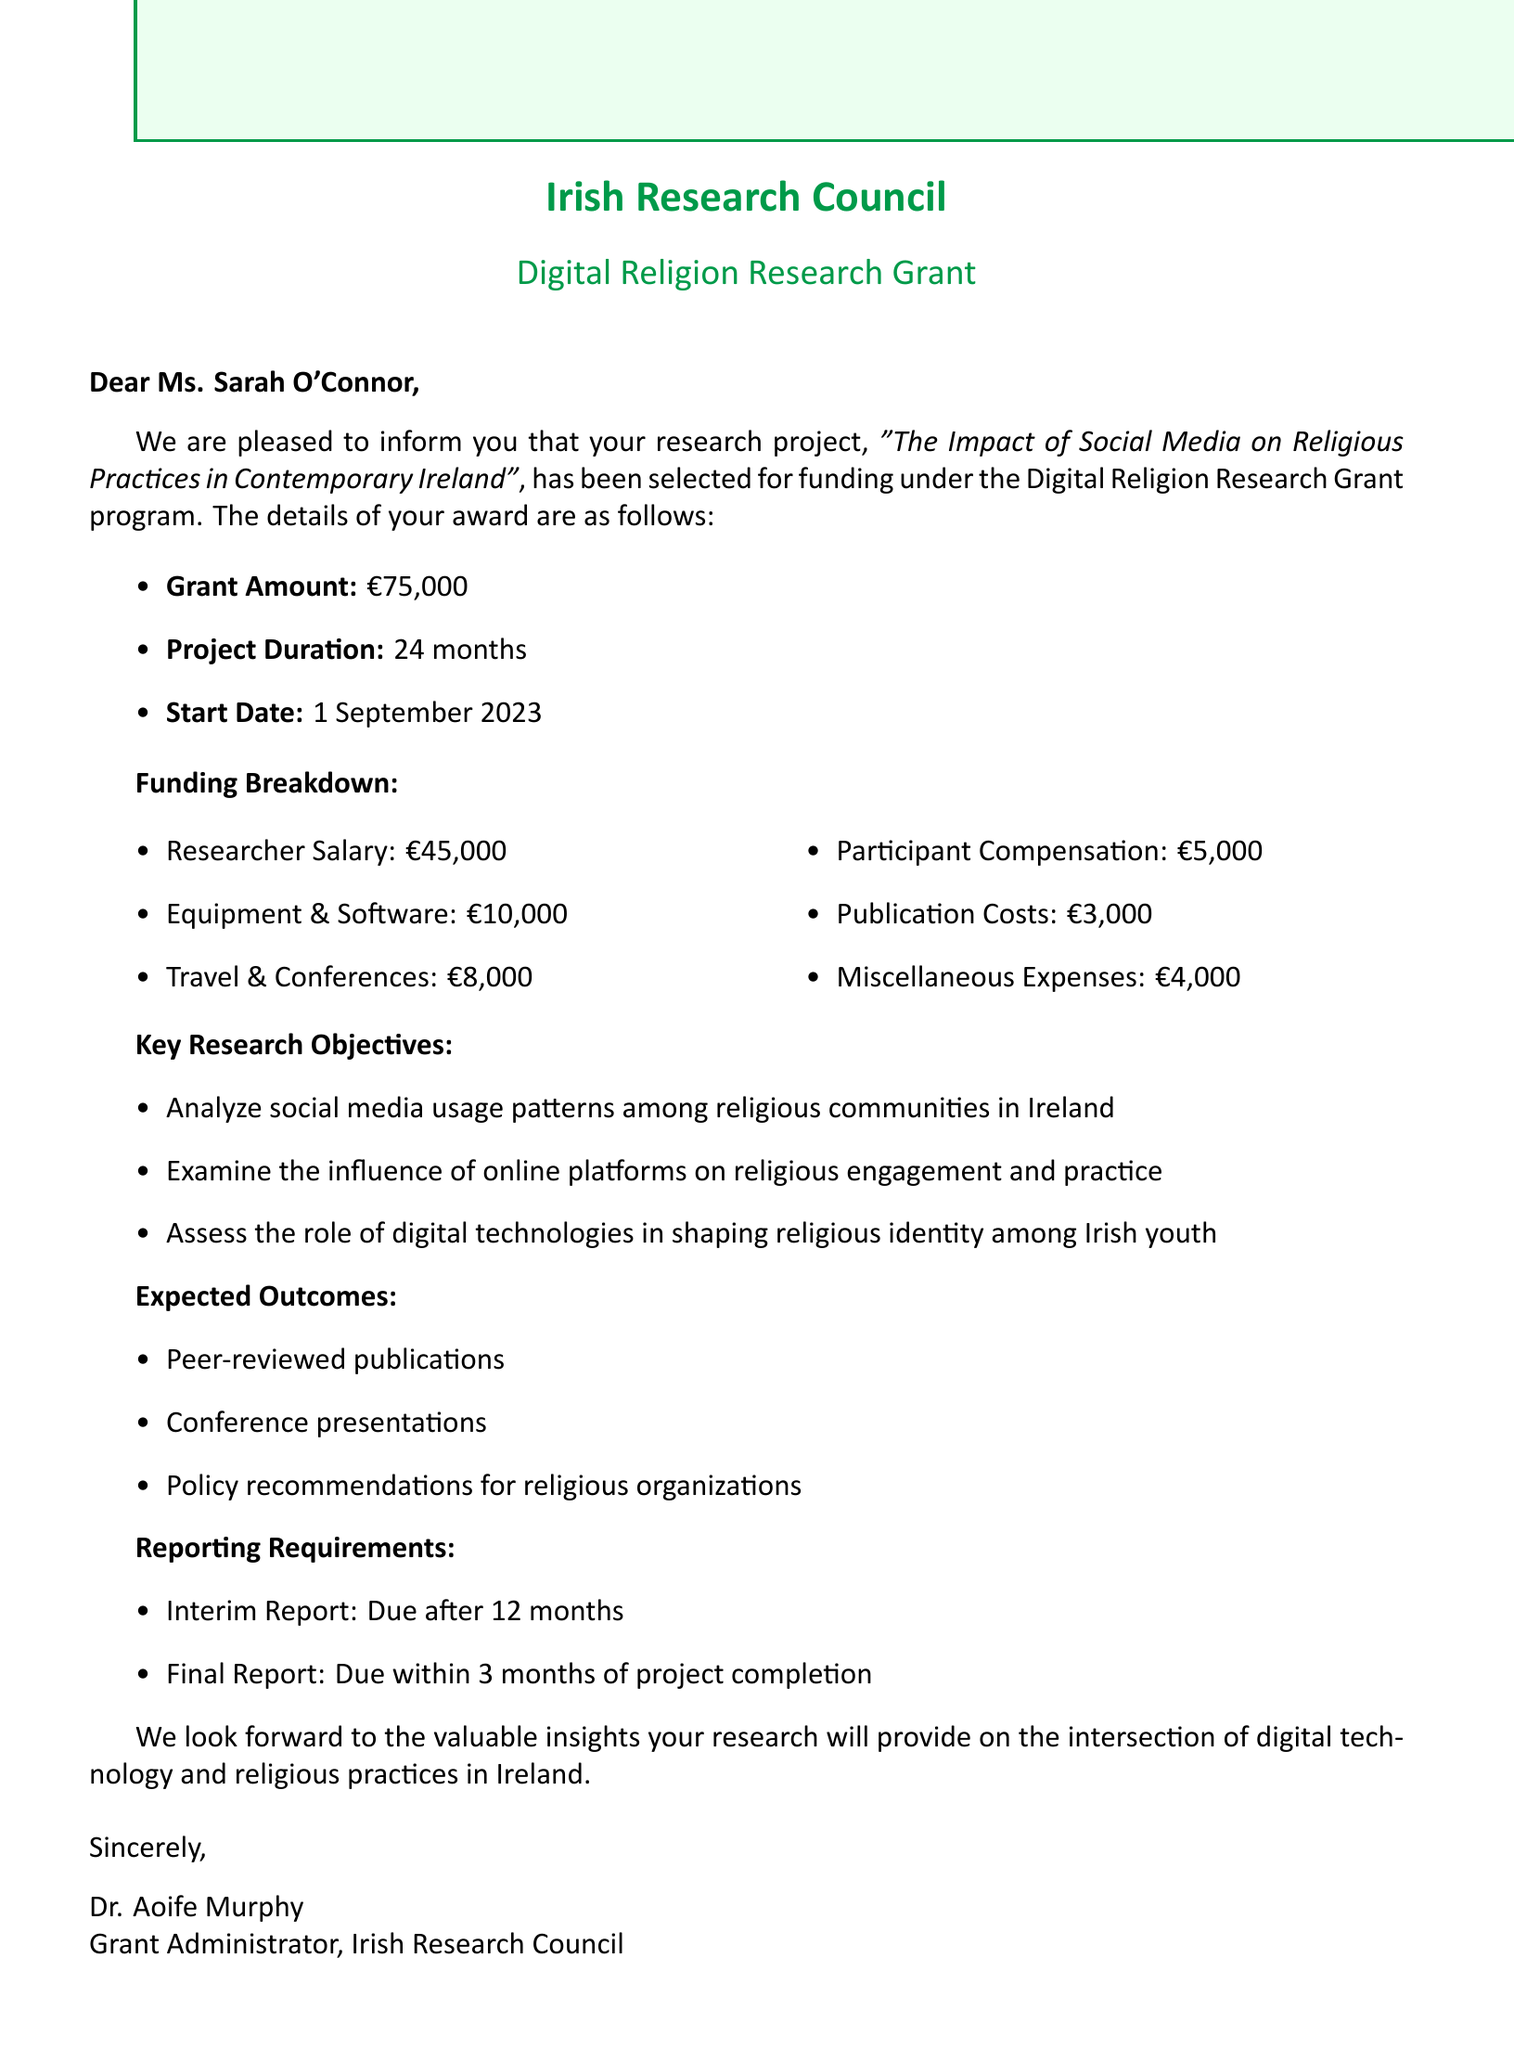What is the recipient's name? The document specifies that the recipient's name is Ms. Sarah O'Connor.
Answer: Ms. Sarah O'Connor What is the grant amount? The grant amount mentioned in the document is €75,000.
Answer: €75,000 How long is the project duration? The duration of the project is explicitly stated as 24 months.
Answer: 24 months When is the start date of the project? The document states that the project is scheduled to start on 1 September 2023.
Answer: 1 September 2023 What are the key research objectives? The document lists three key research objectives related to social media and religious practices.
Answer: Analyze social media usage patterns among religious communities in Ireland, Examine the influence of online platforms on religious engagement and practice, Assess the role of digital technologies in shaping religious identity among Irish youth What percentage of the grant is allocated to researcher salary? The researcher salary allocation is €45,000 out of the total grant of €75,000, which is 60%.
Answer: 60% What is the due date for the interim report? According to the document, the interim report is due after 12 months from the project start date.
Answer: Due after 12 months What is the contact person's name for this grant? The document indicates that the contact person is Dr. Aoife Murphy.
Answer: Dr. Aoife Murphy What type of grants does this document relate to? The document pertains to a specific grant program named Digital Religion Research Grant.
Answer: Digital Religion Research Grant 